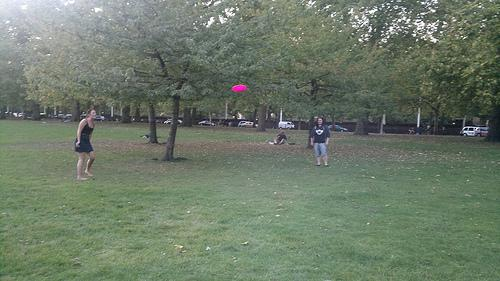Question: why are they at the field?
Choices:
A. To camp.
B. To rest.
C. To ride.
D. To play frisbee.
Answer with the letter. Answer: D Question: where is the guy?
Choices:
A. Standing on the rocks.
B. Sitting on the ground.
C. Sitting in the swing.
D. Laying in the dirt.
Answer with the letter. Answer: B Question: what time of day?
Choices:
A. Afternoon.
B. Morning.
C. Evening.
D. Sunset.
Answer with the letter. Answer: A Question: what are they doing?
Choices:
A. Playing golf.
B. Playing jacks.
C. Playing Frisbee.
D. Playing cards.
Answer with the letter. Answer: C Question: what color is the frisbee?
Choices:
A. Black.
B. Red.
C. Pink.
D. White.
Answer with the letter. Answer: C 